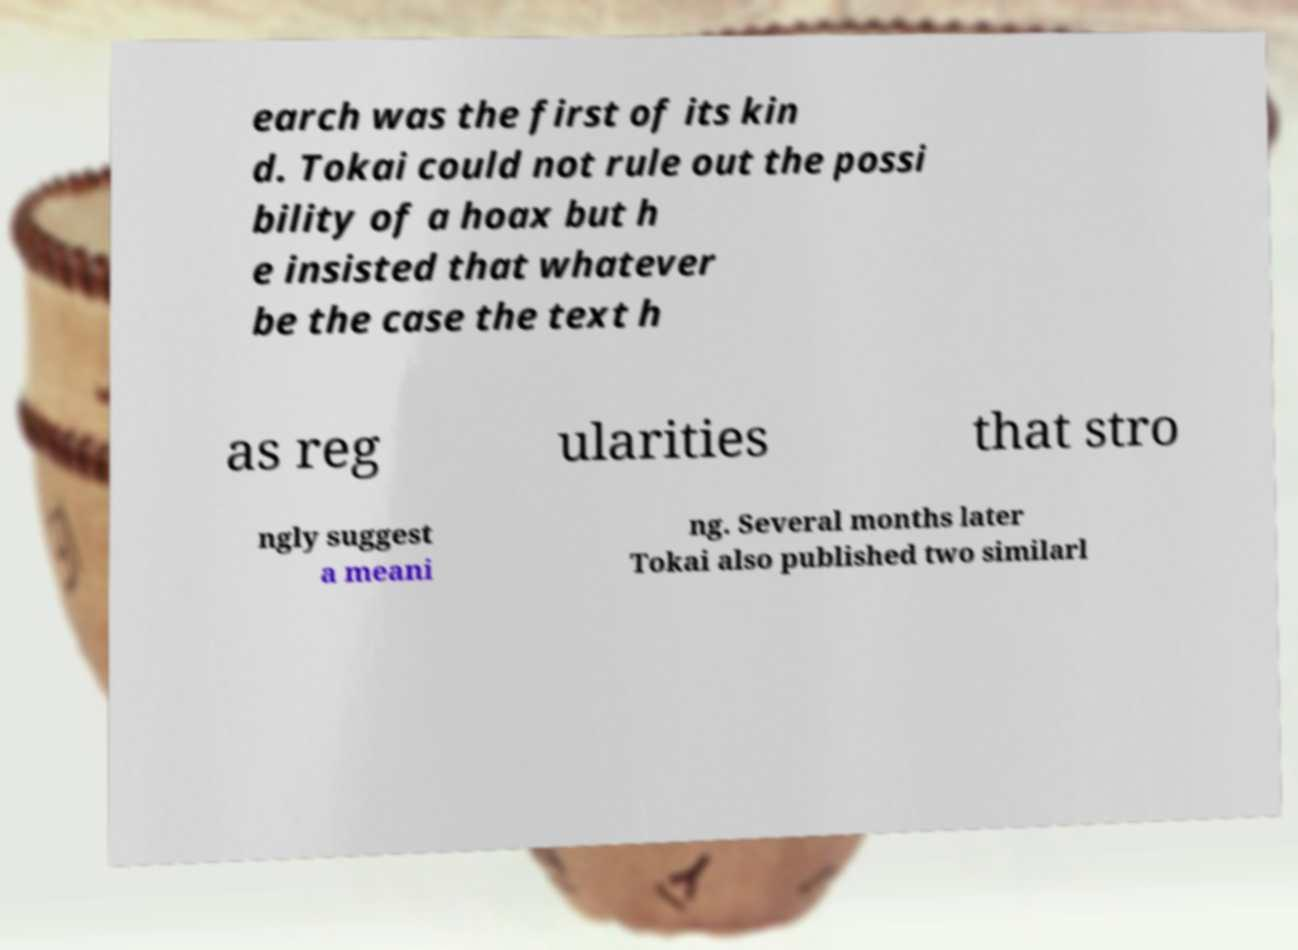Can you read and provide the text displayed in the image?This photo seems to have some interesting text. Can you extract and type it out for me? earch was the first of its kin d. Tokai could not rule out the possi bility of a hoax but h e insisted that whatever be the case the text h as reg ularities that stro ngly suggest a meani ng. Several months later Tokai also published two similarl 